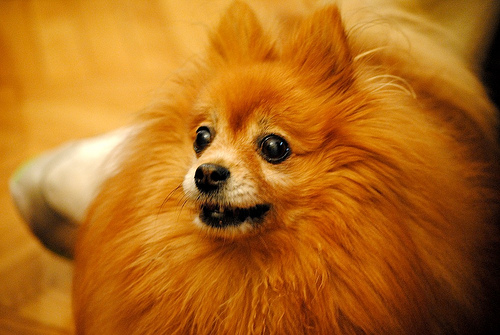<image>
Is there a whisker above the floor? Yes. The whisker is positioned above the floor in the vertical space, higher up in the scene. 